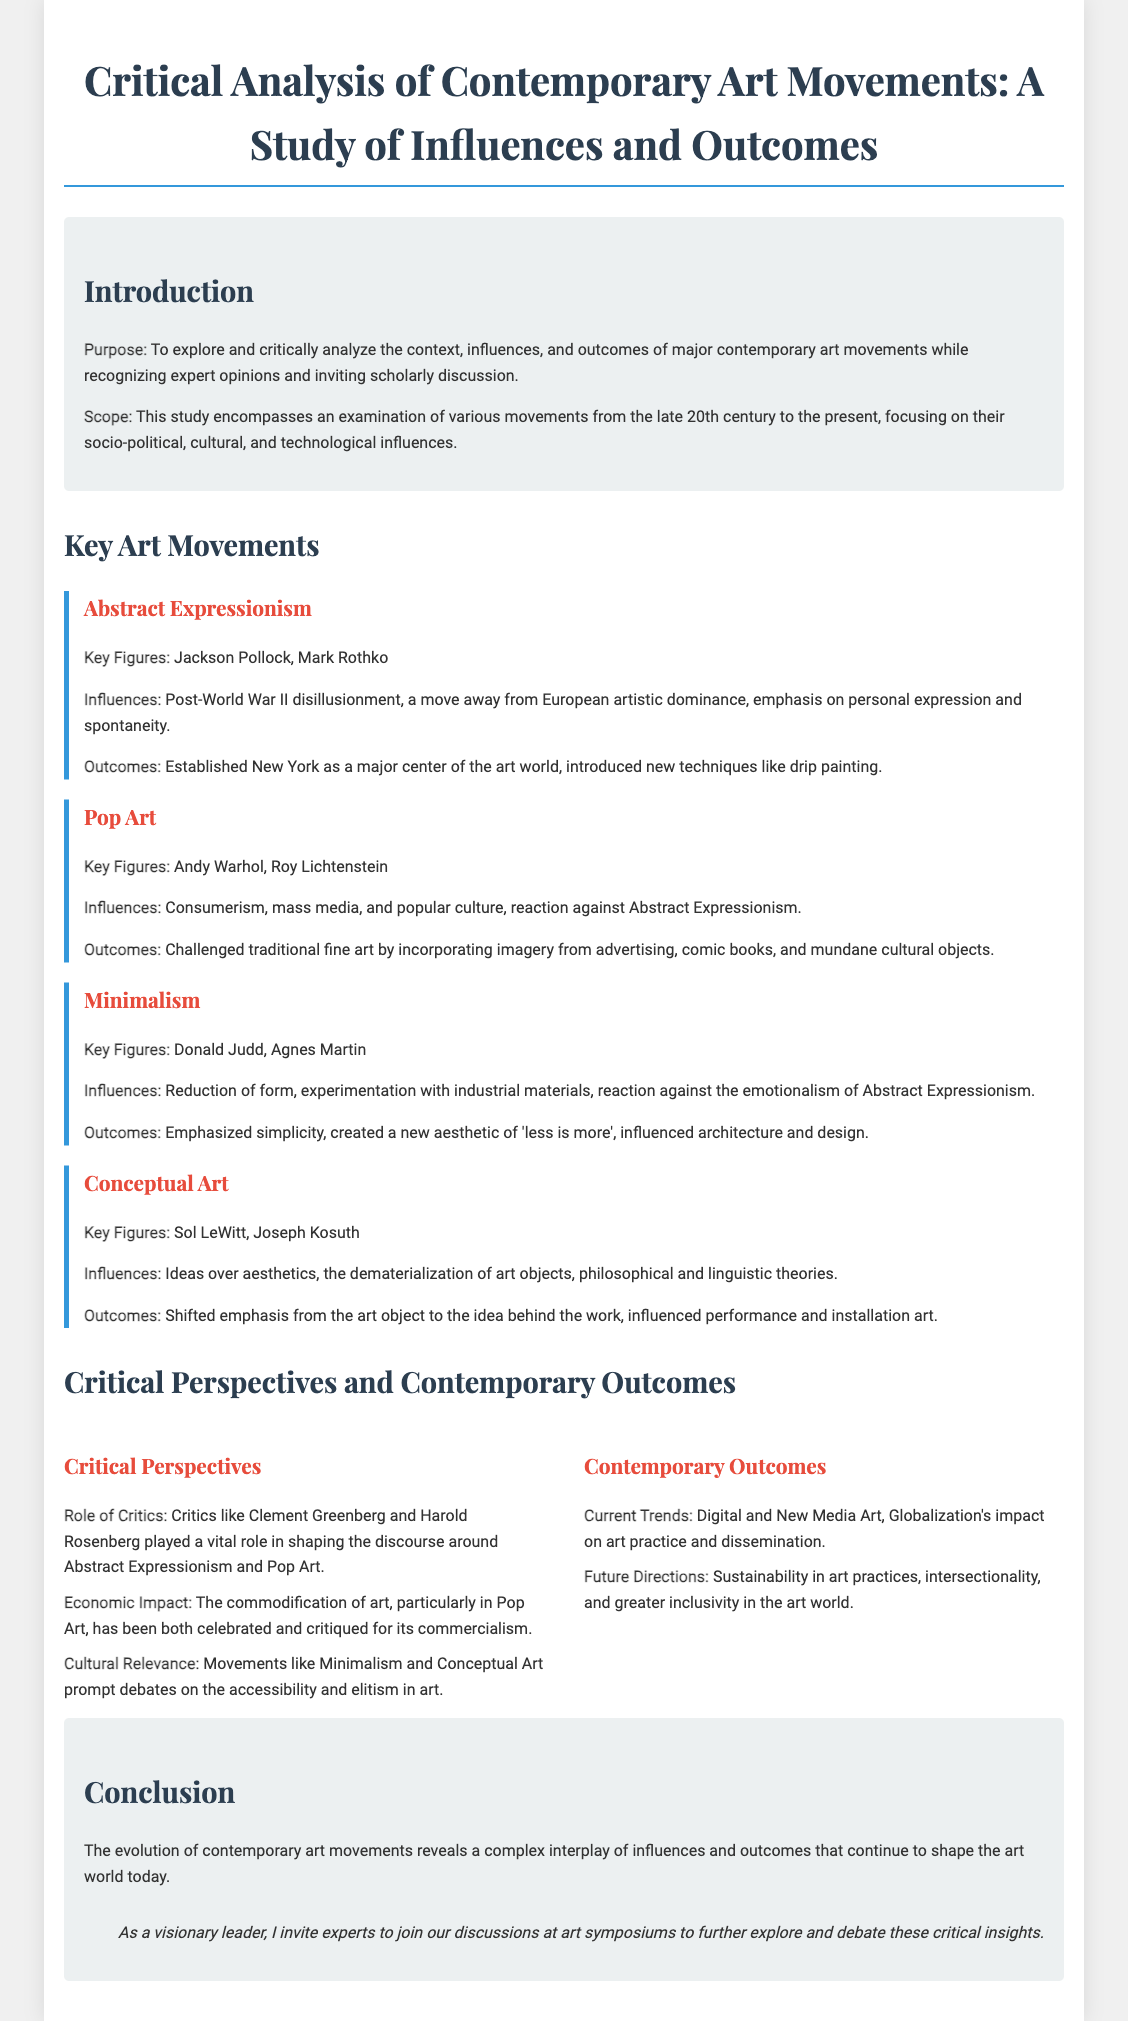What is the title of the document? The title is mentioned prominently at the top of the document indicative of its subject matter.
Answer: Critical Analysis of Contemporary Art Movements: A Study of Influences and Outcomes Who are two key figures of Abstract Expressionism? This information is presented in the section detailing Abstract Expressionism's important contributors.
Answer: Jackson Pollock, Mark Rothko What art movement focuses on consumerism and mass media? The question pertains to a specific contemporary art movement discussed in the document.
Answer: Pop Art What does Minimalism emphasize according to the outcomes? This refers to a key point made in the Outcomes section of the Minimalism art movement.
Answer: Simplicity Which critical perspective discusses the commodification of art? The document states various critical perspectives associated with the discussed art movements.
Answer: Economic Impact What is one current trend in contemporary outcomes? The document outlines current trends in the context of contemporary art movements.
Answer: Digital and New Media Art Who played a vital role in shaping the discourse around Abstract Expressionism? The question seeks information on influential critics mentioned in the document.
Answer: Clement Greenberg What is the purpose of the study according to the introduction? This is a specific detail highlighted in the introduction of the document related to its objectives.
Answer: To explore and critically analyze the context, influences, and outcomes of major contemporary art movements while recognizing expert opinions and inviting scholarly discussion 